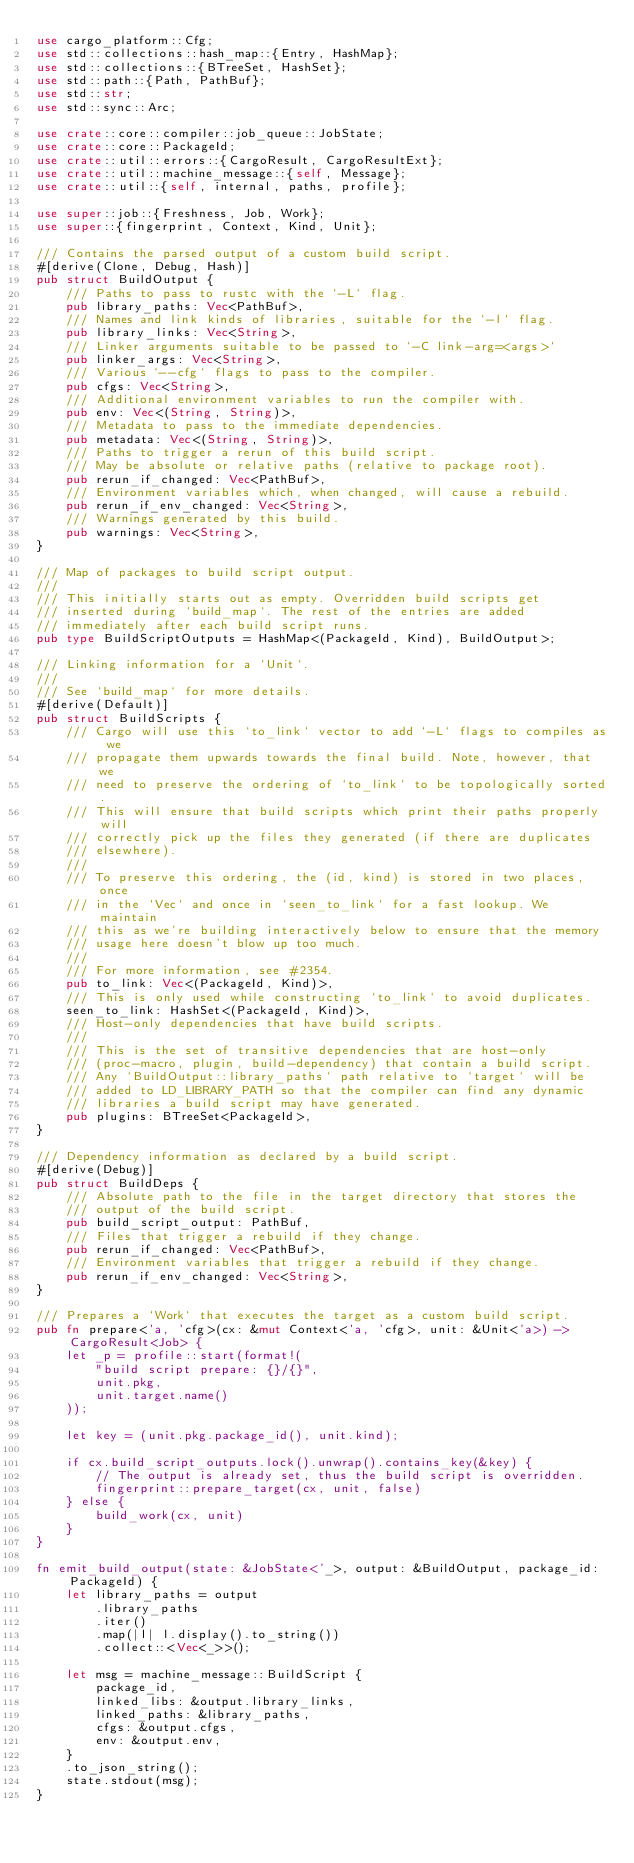Convert code to text. <code><loc_0><loc_0><loc_500><loc_500><_Rust_>use cargo_platform::Cfg;
use std::collections::hash_map::{Entry, HashMap};
use std::collections::{BTreeSet, HashSet};
use std::path::{Path, PathBuf};
use std::str;
use std::sync::Arc;

use crate::core::compiler::job_queue::JobState;
use crate::core::PackageId;
use crate::util::errors::{CargoResult, CargoResultExt};
use crate::util::machine_message::{self, Message};
use crate::util::{self, internal, paths, profile};

use super::job::{Freshness, Job, Work};
use super::{fingerprint, Context, Kind, Unit};

/// Contains the parsed output of a custom build script.
#[derive(Clone, Debug, Hash)]
pub struct BuildOutput {
    /// Paths to pass to rustc with the `-L` flag.
    pub library_paths: Vec<PathBuf>,
    /// Names and link kinds of libraries, suitable for the `-l` flag.
    pub library_links: Vec<String>,
    /// Linker arguments suitable to be passed to `-C link-arg=<args>`
    pub linker_args: Vec<String>,
    /// Various `--cfg` flags to pass to the compiler.
    pub cfgs: Vec<String>,
    /// Additional environment variables to run the compiler with.
    pub env: Vec<(String, String)>,
    /// Metadata to pass to the immediate dependencies.
    pub metadata: Vec<(String, String)>,
    /// Paths to trigger a rerun of this build script.
    /// May be absolute or relative paths (relative to package root).
    pub rerun_if_changed: Vec<PathBuf>,
    /// Environment variables which, when changed, will cause a rebuild.
    pub rerun_if_env_changed: Vec<String>,
    /// Warnings generated by this build.
    pub warnings: Vec<String>,
}

/// Map of packages to build script output.
///
/// This initially starts out as empty. Overridden build scripts get
/// inserted during `build_map`. The rest of the entries are added
/// immediately after each build script runs.
pub type BuildScriptOutputs = HashMap<(PackageId, Kind), BuildOutput>;

/// Linking information for a `Unit`.
///
/// See `build_map` for more details.
#[derive(Default)]
pub struct BuildScripts {
    /// Cargo will use this `to_link` vector to add `-L` flags to compiles as we
    /// propagate them upwards towards the final build. Note, however, that we
    /// need to preserve the ordering of `to_link` to be topologically sorted.
    /// This will ensure that build scripts which print their paths properly will
    /// correctly pick up the files they generated (if there are duplicates
    /// elsewhere).
    ///
    /// To preserve this ordering, the (id, kind) is stored in two places, once
    /// in the `Vec` and once in `seen_to_link` for a fast lookup. We maintain
    /// this as we're building interactively below to ensure that the memory
    /// usage here doesn't blow up too much.
    ///
    /// For more information, see #2354.
    pub to_link: Vec<(PackageId, Kind)>,
    /// This is only used while constructing `to_link` to avoid duplicates.
    seen_to_link: HashSet<(PackageId, Kind)>,
    /// Host-only dependencies that have build scripts.
    ///
    /// This is the set of transitive dependencies that are host-only
    /// (proc-macro, plugin, build-dependency) that contain a build script.
    /// Any `BuildOutput::library_paths` path relative to `target` will be
    /// added to LD_LIBRARY_PATH so that the compiler can find any dynamic
    /// libraries a build script may have generated.
    pub plugins: BTreeSet<PackageId>,
}

/// Dependency information as declared by a build script.
#[derive(Debug)]
pub struct BuildDeps {
    /// Absolute path to the file in the target directory that stores the
    /// output of the build script.
    pub build_script_output: PathBuf,
    /// Files that trigger a rebuild if they change.
    pub rerun_if_changed: Vec<PathBuf>,
    /// Environment variables that trigger a rebuild if they change.
    pub rerun_if_env_changed: Vec<String>,
}

/// Prepares a `Work` that executes the target as a custom build script.
pub fn prepare<'a, 'cfg>(cx: &mut Context<'a, 'cfg>, unit: &Unit<'a>) -> CargoResult<Job> {
    let _p = profile::start(format!(
        "build script prepare: {}/{}",
        unit.pkg,
        unit.target.name()
    ));

    let key = (unit.pkg.package_id(), unit.kind);

    if cx.build_script_outputs.lock().unwrap().contains_key(&key) {
        // The output is already set, thus the build script is overridden.
        fingerprint::prepare_target(cx, unit, false)
    } else {
        build_work(cx, unit)
    }
}

fn emit_build_output(state: &JobState<'_>, output: &BuildOutput, package_id: PackageId) {
    let library_paths = output
        .library_paths
        .iter()
        .map(|l| l.display().to_string())
        .collect::<Vec<_>>();

    let msg = machine_message::BuildScript {
        package_id,
        linked_libs: &output.library_links,
        linked_paths: &library_paths,
        cfgs: &output.cfgs,
        env: &output.env,
    }
    .to_json_string();
    state.stdout(msg);
}
</code> 